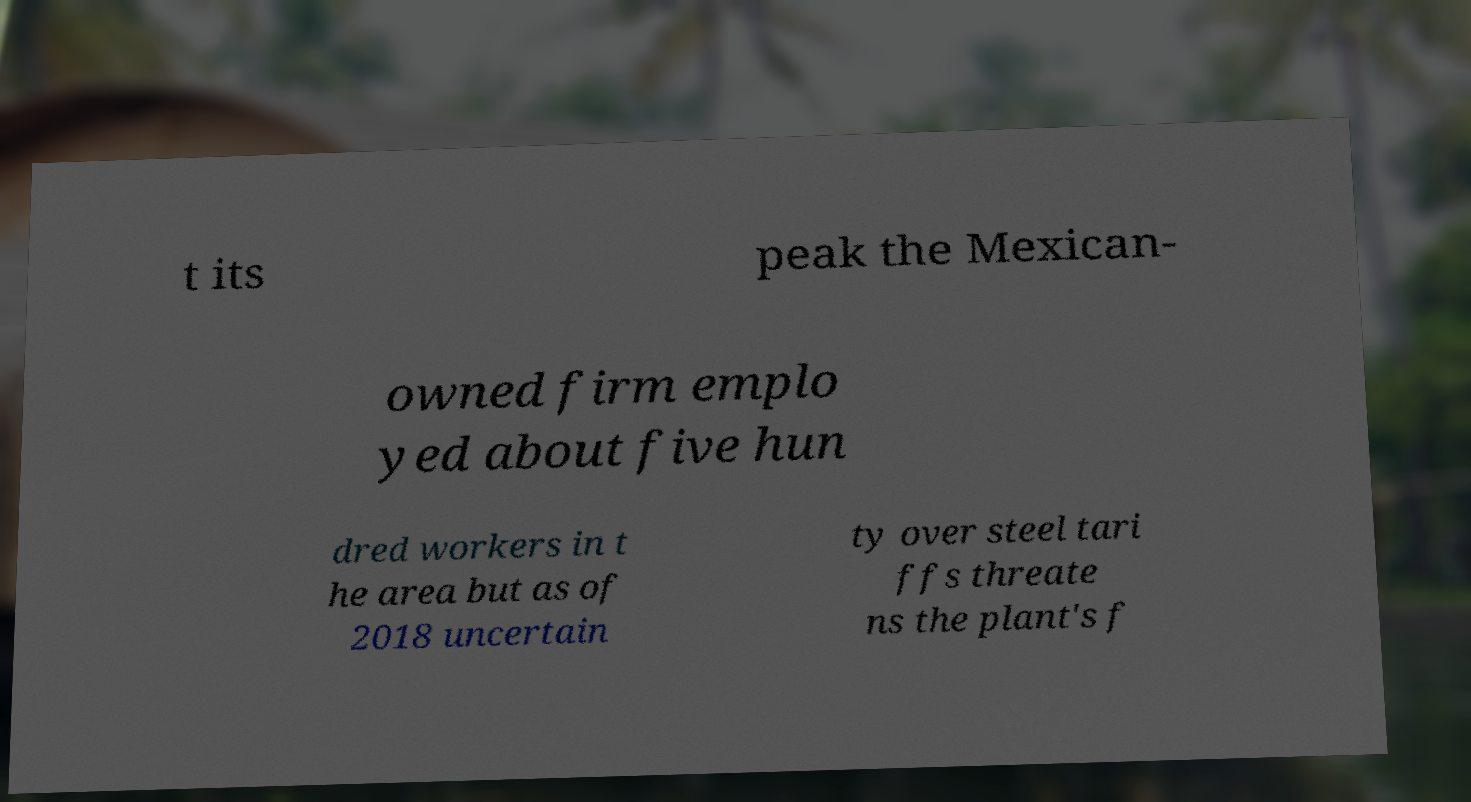Can you read and provide the text displayed in the image?This photo seems to have some interesting text. Can you extract and type it out for me? t its peak the Mexican- owned firm emplo yed about five hun dred workers in t he area but as of 2018 uncertain ty over steel tari ffs threate ns the plant's f 